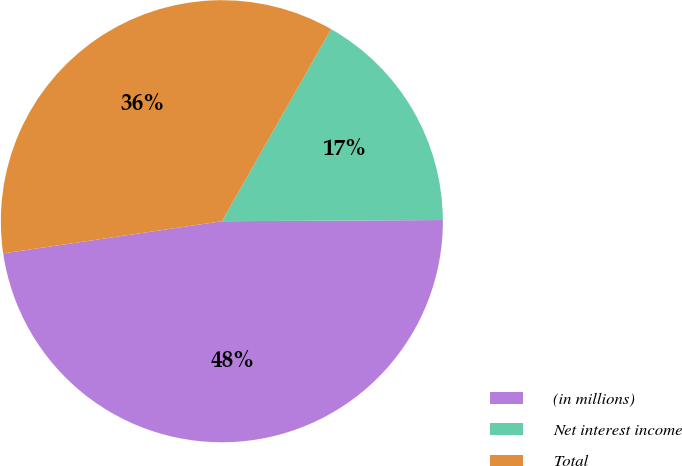Convert chart to OTSL. <chart><loc_0><loc_0><loc_500><loc_500><pie_chart><fcel>(in millions)<fcel>Net interest income<fcel>Total<nl><fcel>47.76%<fcel>16.68%<fcel>35.56%<nl></chart> 